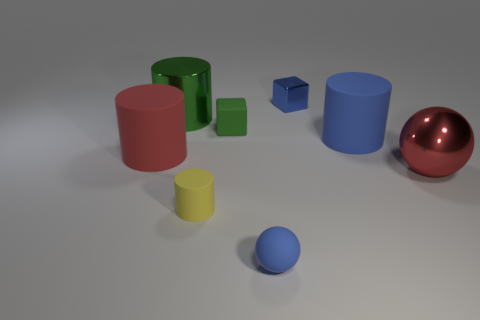How many other things are the same material as the big red ball?
Your answer should be very brief. 2. Is the small yellow object made of the same material as the tiny thing behind the green cylinder?
Your response must be concise. No. Are there fewer large green metal cylinders in front of the tiny yellow matte cylinder than red metal balls that are on the left side of the small blue cube?
Your answer should be compact. No. What is the color of the metallic object that is on the left side of the blue cube?
Provide a succinct answer. Green. What number of other objects are there of the same color as the big metal sphere?
Your answer should be very brief. 1. Do the red object that is right of the metallic cylinder and the big red rubber object have the same size?
Your answer should be very brief. Yes. Are there the same number of blue metal objects and large cyan metallic objects?
Ensure brevity in your answer.  No. How many tiny yellow things are in front of the yellow rubber thing?
Offer a terse response. 0. Is there a green block that has the same size as the blue metallic thing?
Offer a very short reply. Yes. Do the metal sphere and the metallic cylinder have the same color?
Your response must be concise. No. 